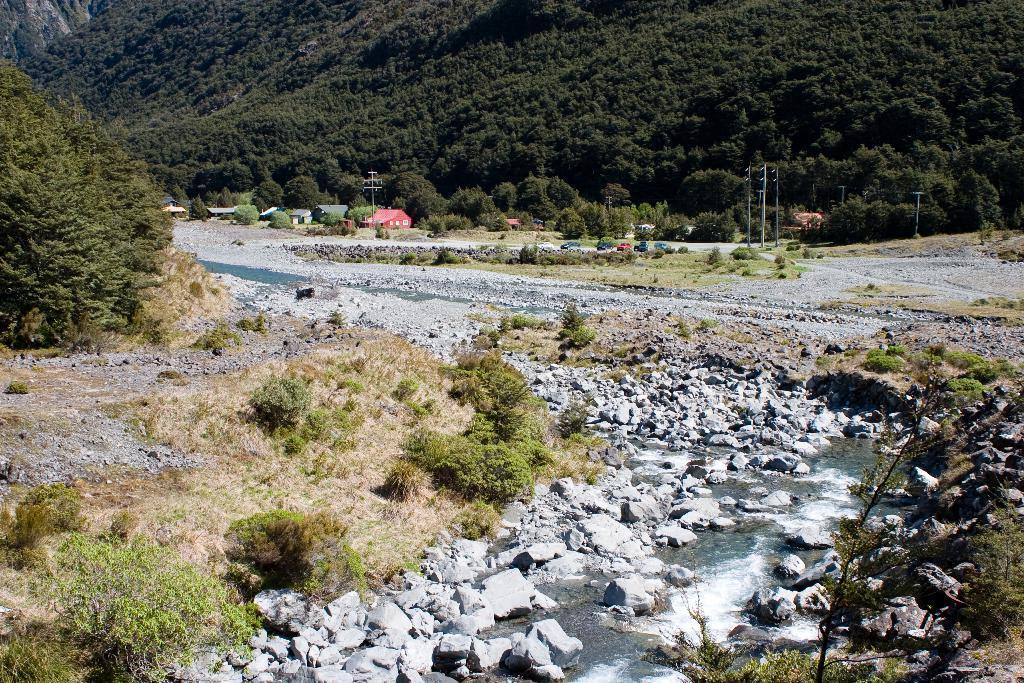In one or two sentences, can you explain what this image depicts? In this image there are rocks, plants, water. At the bottom of the image there is grass on the surface. In the background of the image there are trees, buildings, cars and light poles. 